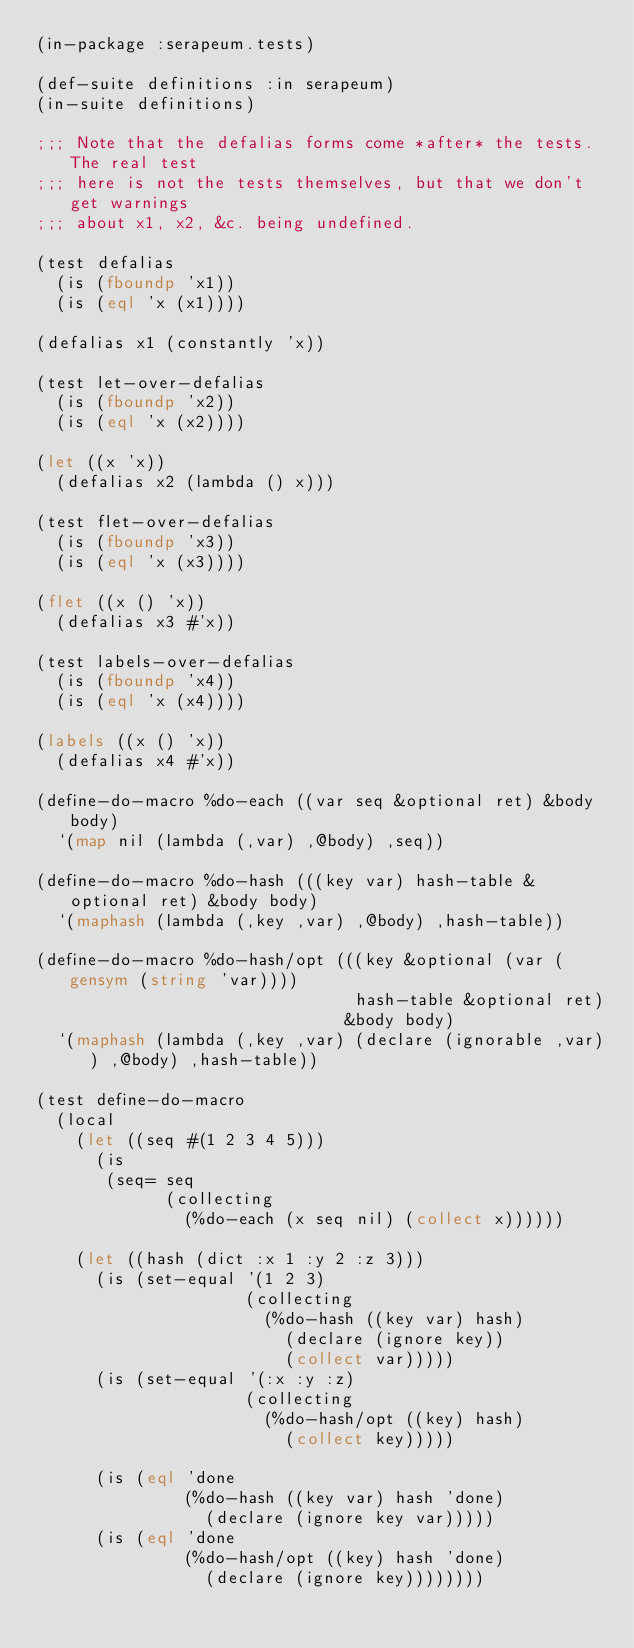Convert code to text. <code><loc_0><loc_0><loc_500><loc_500><_Lisp_>(in-package :serapeum.tests)

(def-suite definitions :in serapeum)
(in-suite definitions)

;;; Note that the defalias forms come *after* the tests. The real test
;;; here is not the tests themselves, but that we don't get warnings
;;; about x1, x2, &c. being undefined.

(test defalias
  (is (fboundp 'x1))
  (is (eql 'x (x1))))

(defalias x1 (constantly 'x))

(test let-over-defalias
  (is (fboundp 'x2))
  (is (eql 'x (x2))))

(let ((x 'x))
  (defalias x2 (lambda () x)))

(test flet-over-defalias
  (is (fboundp 'x3))
  (is (eql 'x (x3))))

(flet ((x () 'x))
  (defalias x3 #'x))

(test labels-over-defalias
  (is (fboundp 'x4))
  (is (eql 'x (x4))))

(labels ((x () 'x))
  (defalias x4 #'x))

(define-do-macro %do-each ((var seq &optional ret) &body body)
  `(map nil (lambda (,var) ,@body) ,seq))

(define-do-macro %do-hash (((key var) hash-table &optional ret) &body body)
  `(maphash (lambda (,key ,var) ,@body) ,hash-table))

(define-do-macro %do-hash/opt (((key &optional (var (gensym (string 'var))))
                                hash-table &optional ret)
                               &body body)
  `(maphash (lambda (,key ,var) (declare (ignorable ,var)) ,@body) ,hash-table))

(test define-do-macro
  (local
    (let ((seq #(1 2 3 4 5)))
      (is
       (seq= seq
             (collecting
               (%do-each (x seq nil) (collect x))))))

    (let ((hash (dict :x 1 :y 2 :z 3)))
      (is (set-equal '(1 2 3)
                     (collecting
                       (%do-hash ((key var) hash)
                         (declare (ignore key))
                         (collect var)))))
      (is (set-equal '(:x :y :z)
                     (collecting
                       (%do-hash/opt ((key) hash)
                         (collect key)))))

      (is (eql 'done
               (%do-hash ((key var) hash 'done)
                 (declare (ignore key var)))))
      (is (eql 'done
               (%do-hash/opt ((key) hash 'done)
                 (declare (ignore key))))))))
</code> 